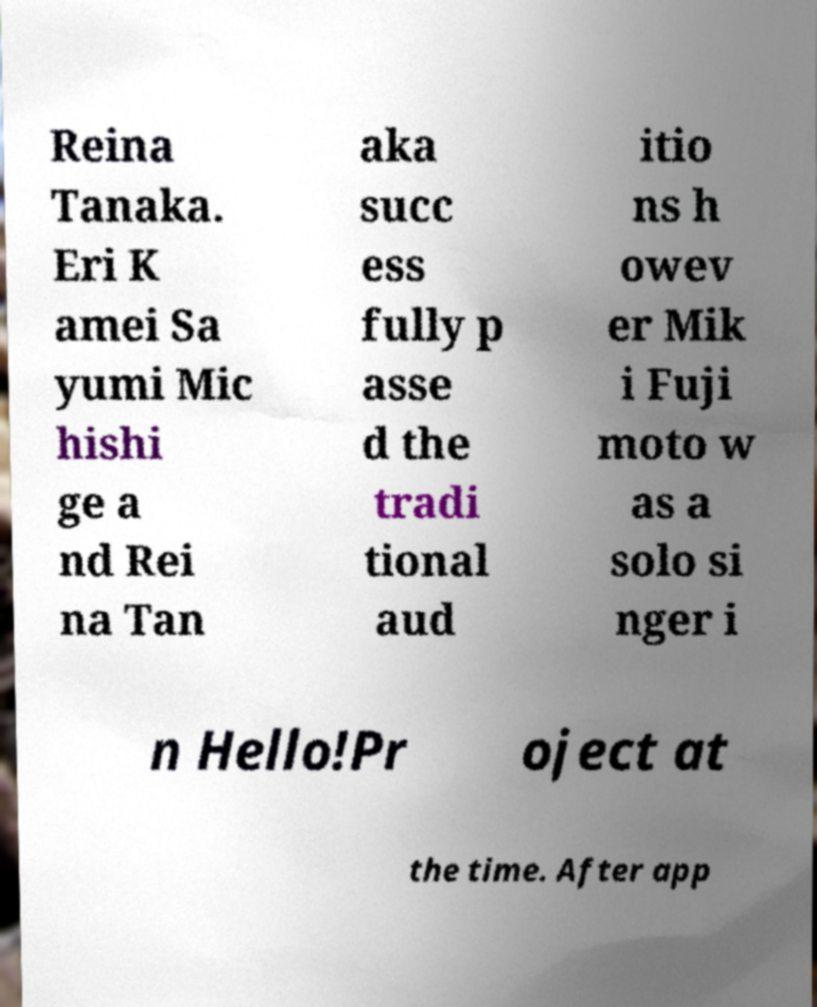For documentation purposes, I need the text within this image transcribed. Could you provide that? Reina Tanaka. Eri K amei Sa yumi Mic hishi ge a nd Rei na Tan aka succ ess fully p asse d the tradi tional aud itio ns h owev er Mik i Fuji moto w as a solo si nger i n Hello!Pr oject at the time. After app 